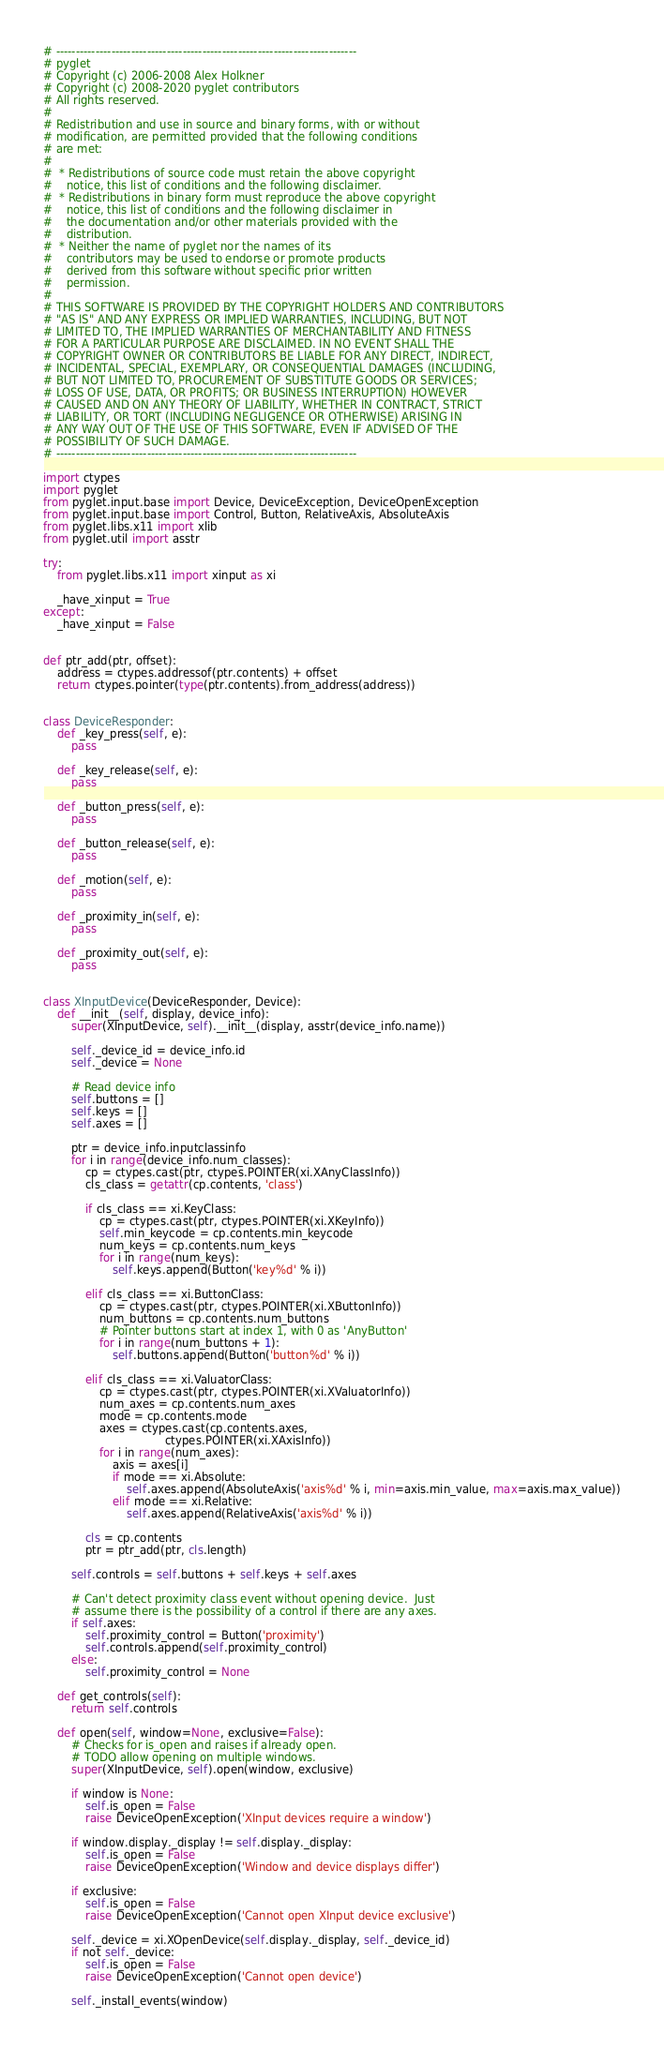<code> <loc_0><loc_0><loc_500><loc_500><_Python_># ----------------------------------------------------------------------------
# pyglet
# Copyright (c) 2006-2008 Alex Holkner
# Copyright (c) 2008-2020 pyglet contributors
# All rights reserved.
#
# Redistribution and use in source and binary forms, with or without
# modification, are permitted provided that the following conditions
# are met:
#
#  * Redistributions of source code must retain the above copyright
#    notice, this list of conditions and the following disclaimer.
#  * Redistributions in binary form must reproduce the above copyright
#    notice, this list of conditions and the following disclaimer in
#    the documentation and/or other materials provided with the
#    distribution.
#  * Neither the name of pyglet nor the names of its
#    contributors may be used to endorse or promote products
#    derived from this software without specific prior written
#    permission.
#
# THIS SOFTWARE IS PROVIDED BY THE COPYRIGHT HOLDERS AND CONTRIBUTORS
# "AS IS" AND ANY EXPRESS OR IMPLIED WARRANTIES, INCLUDING, BUT NOT
# LIMITED TO, THE IMPLIED WARRANTIES OF MERCHANTABILITY AND FITNESS
# FOR A PARTICULAR PURPOSE ARE DISCLAIMED. IN NO EVENT SHALL THE
# COPYRIGHT OWNER OR CONTRIBUTORS BE LIABLE FOR ANY DIRECT, INDIRECT,
# INCIDENTAL, SPECIAL, EXEMPLARY, OR CONSEQUENTIAL DAMAGES (INCLUDING,
# BUT NOT LIMITED TO, PROCUREMENT OF SUBSTITUTE GOODS OR SERVICES;
# LOSS OF USE, DATA, OR PROFITS; OR BUSINESS INTERRUPTION) HOWEVER
# CAUSED AND ON ANY THEORY OF LIABILITY, WHETHER IN CONTRACT, STRICT
# LIABILITY, OR TORT (INCLUDING NEGLIGENCE OR OTHERWISE) ARISING IN
# ANY WAY OUT OF THE USE OF THIS SOFTWARE, EVEN IF ADVISED OF THE
# POSSIBILITY OF SUCH DAMAGE.
# ----------------------------------------------------------------------------

import ctypes
import pyglet
from pyglet.input.base import Device, DeviceException, DeviceOpenException
from pyglet.input.base import Control, Button, RelativeAxis, AbsoluteAxis
from pyglet.libs.x11 import xlib
from pyglet.util import asstr

try:
    from pyglet.libs.x11 import xinput as xi

    _have_xinput = True
except:
    _have_xinput = False


def ptr_add(ptr, offset):
    address = ctypes.addressof(ptr.contents) + offset
    return ctypes.pointer(type(ptr.contents).from_address(address))


class DeviceResponder:
    def _key_press(self, e):
        pass

    def _key_release(self, e):
        pass

    def _button_press(self, e):
        pass

    def _button_release(self, e):
        pass

    def _motion(self, e):
        pass

    def _proximity_in(self, e):
        pass

    def _proximity_out(self, e):
        pass


class XInputDevice(DeviceResponder, Device):
    def __init__(self, display, device_info):
        super(XInputDevice, self).__init__(display, asstr(device_info.name))

        self._device_id = device_info.id
        self._device = None

        # Read device info
        self.buttons = []
        self.keys = []
        self.axes = []

        ptr = device_info.inputclassinfo
        for i in range(device_info.num_classes):
            cp = ctypes.cast(ptr, ctypes.POINTER(xi.XAnyClassInfo))
            cls_class = getattr(cp.contents, 'class')

            if cls_class == xi.KeyClass:
                cp = ctypes.cast(ptr, ctypes.POINTER(xi.XKeyInfo))
                self.min_keycode = cp.contents.min_keycode
                num_keys = cp.contents.num_keys
                for i in range(num_keys):
                    self.keys.append(Button('key%d' % i))

            elif cls_class == xi.ButtonClass:
                cp = ctypes.cast(ptr, ctypes.POINTER(xi.XButtonInfo))
                num_buttons = cp.contents.num_buttons
                # Pointer buttons start at index 1, with 0 as 'AnyButton'
                for i in range(num_buttons + 1):
                    self.buttons.append(Button('button%d' % i))

            elif cls_class == xi.ValuatorClass:
                cp = ctypes.cast(ptr, ctypes.POINTER(xi.XValuatorInfo))
                num_axes = cp.contents.num_axes
                mode = cp.contents.mode
                axes = ctypes.cast(cp.contents.axes,
                                   ctypes.POINTER(xi.XAxisInfo))
                for i in range(num_axes):
                    axis = axes[i]
                    if mode == xi.Absolute:
                        self.axes.append(AbsoluteAxis('axis%d' % i, min=axis.min_value, max=axis.max_value))
                    elif mode == xi.Relative:
                        self.axes.append(RelativeAxis('axis%d' % i))

            cls = cp.contents
            ptr = ptr_add(ptr, cls.length)

        self.controls = self.buttons + self.keys + self.axes

        # Can't detect proximity class event without opening device.  Just
        # assume there is the possibility of a control if there are any axes.
        if self.axes:
            self.proximity_control = Button('proximity')
            self.controls.append(self.proximity_control)
        else:
            self.proximity_control = None

    def get_controls(self):
        return self.controls

    def open(self, window=None, exclusive=False):
        # Checks for is_open and raises if already open.
        # TODO allow opening on multiple windows.
        super(XInputDevice, self).open(window, exclusive)

        if window is None:
            self.is_open = False
            raise DeviceOpenException('XInput devices require a window')

        if window.display._display != self.display._display:
            self.is_open = False
            raise DeviceOpenException('Window and device displays differ')

        if exclusive:
            self.is_open = False
            raise DeviceOpenException('Cannot open XInput device exclusive')

        self._device = xi.XOpenDevice(self.display._display, self._device_id)
        if not self._device:
            self.is_open = False
            raise DeviceOpenException('Cannot open device')

        self._install_events(window)
</code> 